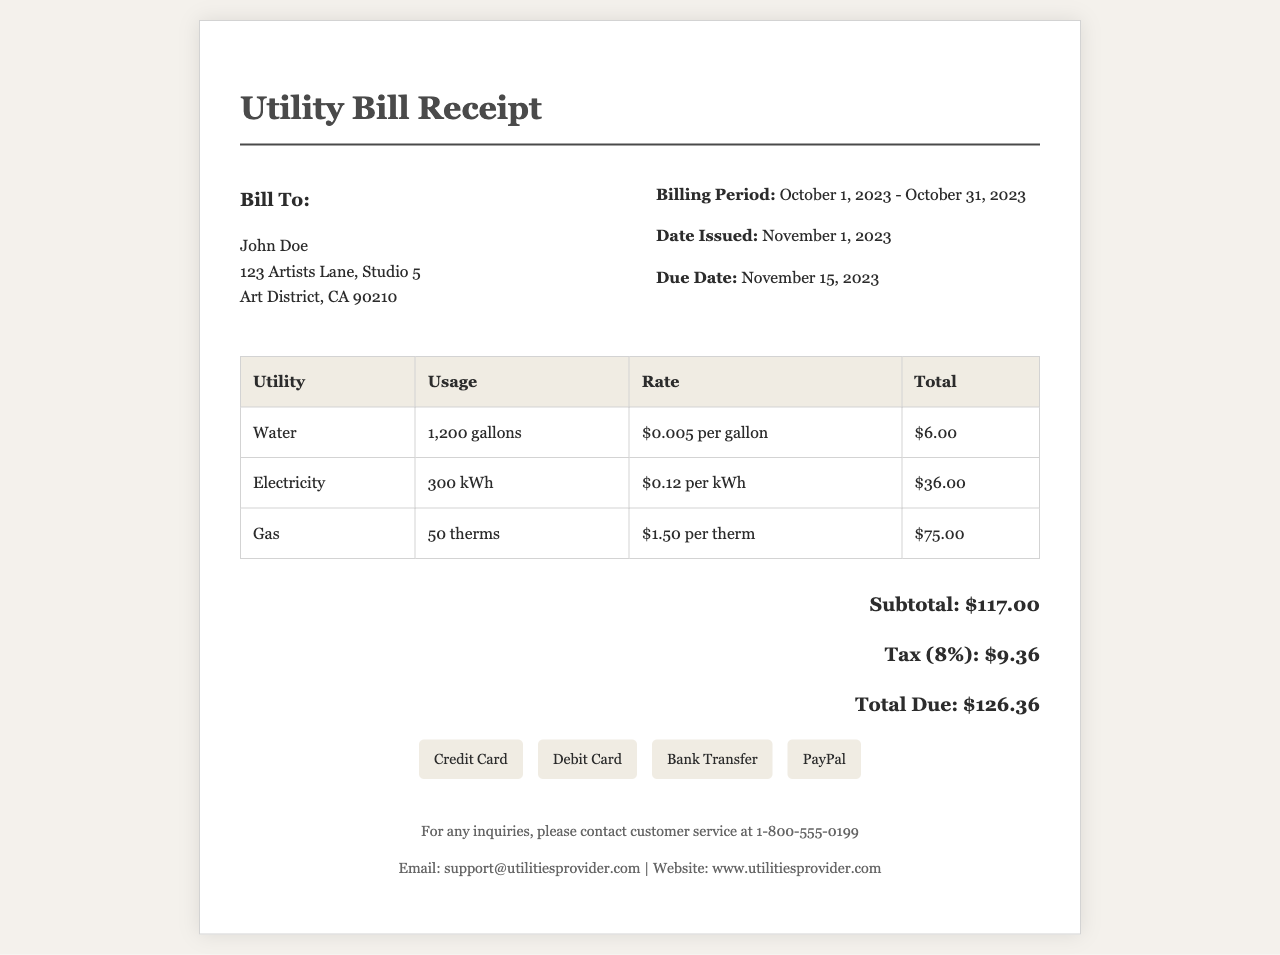What is the billing period? The billing period is specified in the document and indicates the duration that the charges cover, which is from October 1, 2023, to October 31, 2023.
Answer: October 1, 2023 - October 31, 2023 Who is the bill addressed to? The document includes the name of the individual to whom the bill is issued, which is John Doe.
Answer: John Doe What is the total due amount? The total due is the final amount that needs to be paid, which is clearly stated as $126.36 in the document.
Answer: $126.36 What is the rate for electricity usage? The document provides the rate for each utility and the electricity rate is $0.12 per kWh, as shown in the electricity row.
Answer: $0.12 per kWh How much tax was applied? The tax amount is provided in the document and is calculated as 8% of the subtotal, which is $9.36.
Answer: $9.36 What is the total for gas charges? The total amount charged for gas is listed in the breakdown table under gas, which shows $75.00.
Answer: $75.00 What is the subtotal before tax? The subtotal is indicated in the document before any tax is applied and is stated as $117.00.
Answer: $117.00 When is the due date for payment? The due date for payment is specified in the document indicating when the payment should be made, which is November 15, 2023.
Answer: November 15, 2023 What are the available payment methods? The document lists several methods available for payment, indicating various options such as Credit Card, Debit Card, Bank Transfer, and PayPal.
Answer: Credit Card, Debit Card, Bank Transfer, PayPal 